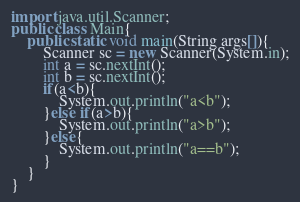Convert code to text. <code><loc_0><loc_0><loc_500><loc_500><_Java_>import java.util.Scanner;
public class Main{
    public static void main(String args[]){
        Scanner sc = new Scanner(System.in);
        int a = sc.nextInt();
        int b = sc.nextInt();
        if(a<b){
            System.out.println("a<b");
        }else if(a>b){
            System.out.println("a>b");
        }else{
            System.out.println("a==b");
        }
    }
}
</code> 